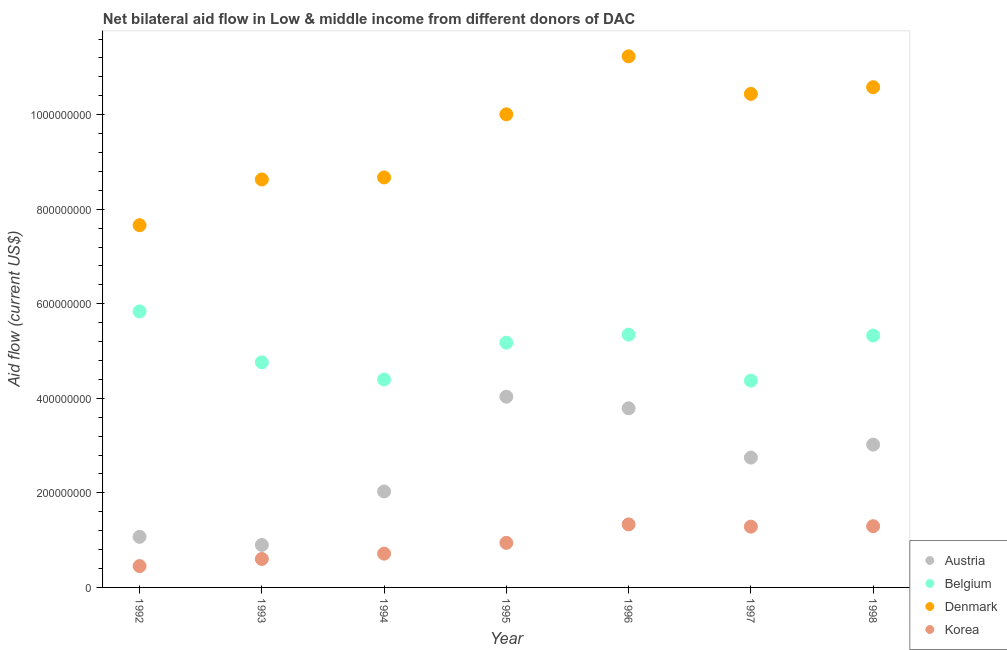What is the amount of aid given by denmark in 1995?
Make the answer very short. 1.00e+09. Across all years, what is the maximum amount of aid given by austria?
Your answer should be very brief. 4.03e+08. Across all years, what is the minimum amount of aid given by belgium?
Give a very brief answer. 4.37e+08. In which year was the amount of aid given by belgium minimum?
Ensure brevity in your answer.  1997. What is the total amount of aid given by austria in the graph?
Offer a terse response. 1.76e+09. What is the difference between the amount of aid given by korea in 1994 and that in 1997?
Your answer should be very brief. -5.71e+07. What is the difference between the amount of aid given by korea in 1998 and the amount of aid given by denmark in 1995?
Provide a short and direct response. -8.71e+08. What is the average amount of aid given by belgium per year?
Your response must be concise. 5.03e+08. In the year 1994, what is the difference between the amount of aid given by korea and amount of aid given by austria?
Make the answer very short. -1.32e+08. In how many years, is the amount of aid given by belgium greater than 1000000000 US$?
Provide a succinct answer. 0. What is the ratio of the amount of aid given by belgium in 1992 to that in 1995?
Provide a succinct answer. 1.13. Is the difference between the amount of aid given by austria in 1995 and 1997 greater than the difference between the amount of aid given by denmark in 1995 and 1997?
Ensure brevity in your answer.  Yes. What is the difference between the highest and the second highest amount of aid given by korea?
Give a very brief answer. 3.80e+06. What is the difference between the highest and the lowest amount of aid given by denmark?
Make the answer very short. 3.57e+08. In how many years, is the amount of aid given by korea greater than the average amount of aid given by korea taken over all years?
Your answer should be very brief. 3. Is the sum of the amount of aid given by austria in 1993 and 1994 greater than the maximum amount of aid given by belgium across all years?
Make the answer very short. No. Is it the case that in every year, the sum of the amount of aid given by belgium and amount of aid given by austria is greater than the sum of amount of aid given by korea and amount of aid given by denmark?
Keep it short and to the point. No. Is it the case that in every year, the sum of the amount of aid given by austria and amount of aid given by belgium is greater than the amount of aid given by denmark?
Provide a short and direct response. No. Does the amount of aid given by austria monotonically increase over the years?
Offer a terse response. No. Is the amount of aid given by korea strictly greater than the amount of aid given by belgium over the years?
Provide a succinct answer. No. Are the values on the major ticks of Y-axis written in scientific E-notation?
Your response must be concise. No. Does the graph contain any zero values?
Make the answer very short. No. Does the graph contain grids?
Your response must be concise. No. What is the title of the graph?
Your answer should be compact. Net bilateral aid flow in Low & middle income from different donors of DAC. What is the label or title of the X-axis?
Make the answer very short. Year. What is the Aid flow (current US$) of Austria in 1992?
Your answer should be very brief. 1.07e+08. What is the Aid flow (current US$) in Belgium in 1992?
Your response must be concise. 5.84e+08. What is the Aid flow (current US$) of Denmark in 1992?
Provide a short and direct response. 7.66e+08. What is the Aid flow (current US$) of Korea in 1992?
Provide a succinct answer. 4.52e+07. What is the Aid flow (current US$) of Austria in 1993?
Make the answer very short. 8.98e+07. What is the Aid flow (current US$) of Belgium in 1993?
Give a very brief answer. 4.76e+08. What is the Aid flow (current US$) in Denmark in 1993?
Keep it short and to the point. 8.63e+08. What is the Aid flow (current US$) in Korea in 1993?
Keep it short and to the point. 6.02e+07. What is the Aid flow (current US$) in Austria in 1994?
Give a very brief answer. 2.03e+08. What is the Aid flow (current US$) of Belgium in 1994?
Offer a very short reply. 4.40e+08. What is the Aid flow (current US$) of Denmark in 1994?
Your answer should be compact. 8.67e+08. What is the Aid flow (current US$) in Korea in 1994?
Ensure brevity in your answer.  7.14e+07. What is the Aid flow (current US$) in Austria in 1995?
Offer a terse response. 4.03e+08. What is the Aid flow (current US$) in Belgium in 1995?
Your answer should be very brief. 5.18e+08. What is the Aid flow (current US$) in Denmark in 1995?
Your response must be concise. 1.00e+09. What is the Aid flow (current US$) of Korea in 1995?
Give a very brief answer. 9.42e+07. What is the Aid flow (current US$) in Austria in 1996?
Give a very brief answer. 3.79e+08. What is the Aid flow (current US$) of Belgium in 1996?
Give a very brief answer. 5.35e+08. What is the Aid flow (current US$) of Denmark in 1996?
Offer a terse response. 1.12e+09. What is the Aid flow (current US$) in Korea in 1996?
Your answer should be compact. 1.33e+08. What is the Aid flow (current US$) of Austria in 1997?
Your response must be concise. 2.75e+08. What is the Aid flow (current US$) of Belgium in 1997?
Give a very brief answer. 4.37e+08. What is the Aid flow (current US$) in Denmark in 1997?
Your answer should be compact. 1.04e+09. What is the Aid flow (current US$) in Korea in 1997?
Provide a succinct answer. 1.29e+08. What is the Aid flow (current US$) in Austria in 1998?
Your answer should be very brief. 3.02e+08. What is the Aid flow (current US$) of Belgium in 1998?
Keep it short and to the point. 5.33e+08. What is the Aid flow (current US$) of Denmark in 1998?
Ensure brevity in your answer.  1.06e+09. What is the Aid flow (current US$) in Korea in 1998?
Give a very brief answer. 1.30e+08. Across all years, what is the maximum Aid flow (current US$) of Austria?
Make the answer very short. 4.03e+08. Across all years, what is the maximum Aid flow (current US$) in Belgium?
Provide a short and direct response. 5.84e+08. Across all years, what is the maximum Aid flow (current US$) in Denmark?
Your answer should be compact. 1.12e+09. Across all years, what is the maximum Aid flow (current US$) of Korea?
Provide a succinct answer. 1.33e+08. Across all years, what is the minimum Aid flow (current US$) of Austria?
Your answer should be very brief. 8.98e+07. Across all years, what is the minimum Aid flow (current US$) of Belgium?
Make the answer very short. 4.37e+08. Across all years, what is the minimum Aid flow (current US$) of Denmark?
Your response must be concise. 7.66e+08. Across all years, what is the minimum Aid flow (current US$) of Korea?
Provide a short and direct response. 4.52e+07. What is the total Aid flow (current US$) in Austria in the graph?
Your response must be concise. 1.76e+09. What is the total Aid flow (current US$) of Belgium in the graph?
Make the answer very short. 3.52e+09. What is the total Aid flow (current US$) of Denmark in the graph?
Your answer should be very brief. 6.72e+09. What is the total Aid flow (current US$) of Korea in the graph?
Offer a terse response. 6.62e+08. What is the difference between the Aid flow (current US$) in Austria in 1992 and that in 1993?
Keep it short and to the point. 1.72e+07. What is the difference between the Aid flow (current US$) in Belgium in 1992 and that in 1993?
Keep it short and to the point. 1.08e+08. What is the difference between the Aid flow (current US$) in Denmark in 1992 and that in 1993?
Make the answer very short. -9.67e+07. What is the difference between the Aid flow (current US$) in Korea in 1992 and that in 1993?
Keep it short and to the point. -1.50e+07. What is the difference between the Aid flow (current US$) of Austria in 1992 and that in 1994?
Your answer should be compact. -9.60e+07. What is the difference between the Aid flow (current US$) of Belgium in 1992 and that in 1994?
Provide a succinct answer. 1.44e+08. What is the difference between the Aid flow (current US$) of Denmark in 1992 and that in 1994?
Provide a succinct answer. -1.01e+08. What is the difference between the Aid flow (current US$) in Korea in 1992 and that in 1994?
Offer a terse response. -2.63e+07. What is the difference between the Aid flow (current US$) of Austria in 1992 and that in 1995?
Give a very brief answer. -2.96e+08. What is the difference between the Aid flow (current US$) of Belgium in 1992 and that in 1995?
Give a very brief answer. 6.62e+07. What is the difference between the Aid flow (current US$) of Denmark in 1992 and that in 1995?
Your answer should be very brief. -2.35e+08. What is the difference between the Aid flow (current US$) in Korea in 1992 and that in 1995?
Your answer should be compact. -4.91e+07. What is the difference between the Aid flow (current US$) in Austria in 1992 and that in 1996?
Your answer should be compact. -2.72e+08. What is the difference between the Aid flow (current US$) in Belgium in 1992 and that in 1996?
Provide a short and direct response. 4.92e+07. What is the difference between the Aid flow (current US$) in Denmark in 1992 and that in 1996?
Ensure brevity in your answer.  -3.57e+08. What is the difference between the Aid flow (current US$) of Korea in 1992 and that in 1996?
Your response must be concise. -8.82e+07. What is the difference between the Aid flow (current US$) in Austria in 1992 and that in 1997?
Offer a very short reply. -1.68e+08. What is the difference between the Aid flow (current US$) in Belgium in 1992 and that in 1997?
Offer a very short reply. 1.46e+08. What is the difference between the Aid flow (current US$) of Denmark in 1992 and that in 1997?
Your answer should be compact. -2.78e+08. What is the difference between the Aid flow (current US$) in Korea in 1992 and that in 1997?
Offer a terse response. -8.34e+07. What is the difference between the Aid flow (current US$) of Austria in 1992 and that in 1998?
Provide a succinct answer. -1.95e+08. What is the difference between the Aid flow (current US$) of Belgium in 1992 and that in 1998?
Give a very brief answer. 5.10e+07. What is the difference between the Aid flow (current US$) in Denmark in 1992 and that in 1998?
Your answer should be very brief. -2.92e+08. What is the difference between the Aid flow (current US$) of Korea in 1992 and that in 1998?
Make the answer very short. -8.44e+07. What is the difference between the Aid flow (current US$) of Austria in 1993 and that in 1994?
Provide a short and direct response. -1.13e+08. What is the difference between the Aid flow (current US$) in Belgium in 1993 and that in 1994?
Give a very brief answer. 3.64e+07. What is the difference between the Aid flow (current US$) in Denmark in 1993 and that in 1994?
Offer a very short reply. -4.30e+06. What is the difference between the Aid flow (current US$) of Korea in 1993 and that in 1994?
Provide a succinct answer. -1.12e+07. What is the difference between the Aid flow (current US$) in Austria in 1993 and that in 1995?
Provide a succinct answer. -3.14e+08. What is the difference between the Aid flow (current US$) of Belgium in 1993 and that in 1995?
Offer a very short reply. -4.15e+07. What is the difference between the Aid flow (current US$) of Denmark in 1993 and that in 1995?
Provide a short and direct response. -1.38e+08. What is the difference between the Aid flow (current US$) in Korea in 1993 and that in 1995?
Your answer should be very brief. -3.40e+07. What is the difference between the Aid flow (current US$) in Austria in 1993 and that in 1996?
Keep it short and to the point. -2.89e+08. What is the difference between the Aid flow (current US$) of Belgium in 1993 and that in 1996?
Ensure brevity in your answer.  -5.85e+07. What is the difference between the Aid flow (current US$) of Denmark in 1993 and that in 1996?
Your answer should be compact. -2.61e+08. What is the difference between the Aid flow (current US$) in Korea in 1993 and that in 1996?
Keep it short and to the point. -7.31e+07. What is the difference between the Aid flow (current US$) of Austria in 1993 and that in 1997?
Ensure brevity in your answer.  -1.85e+08. What is the difference between the Aid flow (current US$) in Belgium in 1993 and that in 1997?
Provide a succinct answer. 3.87e+07. What is the difference between the Aid flow (current US$) of Denmark in 1993 and that in 1997?
Your answer should be very brief. -1.81e+08. What is the difference between the Aid flow (current US$) in Korea in 1993 and that in 1997?
Give a very brief answer. -6.84e+07. What is the difference between the Aid flow (current US$) in Austria in 1993 and that in 1998?
Your answer should be compact. -2.12e+08. What is the difference between the Aid flow (current US$) in Belgium in 1993 and that in 1998?
Offer a very short reply. -5.66e+07. What is the difference between the Aid flow (current US$) in Denmark in 1993 and that in 1998?
Your answer should be compact. -1.95e+08. What is the difference between the Aid flow (current US$) of Korea in 1993 and that in 1998?
Provide a succinct answer. -6.93e+07. What is the difference between the Aid flow (current US$) in Austria in 1994 and that in 1995?
Provide a short and direct response. -2.00e+08. What is the difference between the Aid flow (current US$) of Belgium in 1994 and that in 1995?
Make the answer very short. -7.78e+07. What is the difference between the Aid flow (current US$) in Denmark in 1994 and that in 1995?
Keep it short and to the point. -1.34e+08. What is the difference between the Aid flow (current US$) in Korea in 1994 and that in 1995?
Ensure brevity in your answer.  -2.28e+07. What is the difference between the Aid flow (current US$) of Austria in 1994 and that in 1996?
Provide a succinct answer. -1.76e+08. What is the difference between the Aid flow (current US$) of Belgium in 1994 and that in 1996?
Keep it short and to the point. -9.49e+07. What is the difference between the Aid flow (current US$) of Denmark in 1994 and that in 1996?
Offer a very short reply. -2.56e+08. What is the difference between the Aid flow (current US$) of Korea in 1994 and that in 1996?
Provide a succinct answer. -6.19e+07. What is the difference between the Aid flow (current US$) of Austria in 1994 and that in 1997?
Provide a short and direct response. -7.16e+07. What is the difference between the Aid flow (current US$) of Belgium in 1994 and that in 1997?
Your answer should be very brief. 2.37e+06. What is the difference between the Aid flow (current US$) of Denmark in 1994 and that in 1997?
Provide a succinct answer. -1.77e+08. What is the difference between the Aid flow (current US$) of Korea in 1994 and that in 1997?
Your response must be concise. -5.71e+07. What is the difference between the Aid flow (current US$) in Austria in 1994 and that in 1998?
Your answer should be very brief. -9.91e+07. What is the difference between the Aid flow (current US$) in Belgium in 1994 and that in 1998?
Give a very brief answer. -9.30e+07. What is the difference between the Aid flow (current US$) in Denmark in 1994 and that in 1998?
Offer a very short reply. -1.91e+08. What is the difference between the Aid flow (current US$) in Korea in 1994 and that in 1998?
Give a very brief answer. -5.81e+07. What is the difference between the Aid flow (current US$) in Austria in 1995 and that in 1996?
Make the answer very short. 2.46e+07. What is the difference between the Aid flow (current US$) in Belgium in 1995 and that in 1996?
Your response must be concise. -1.70e+07. What is the difference between the Aid flow (current US$) of Denmark in 1995 and that in 1996?
Ensure brevity in your answer.  -1.23e+08. What is the difference between the Aid flow (current US$) of Korea in 1995 and that in 1996?
Provide a short and direct response. -3.91e+07. What is the difference between the Aid flow (current US$) in Austria in 1995 and that in 1997?
Offer a terse response. 1.29e+08. What is the difference between the Aid flow (current US$) of Belgium in 1995 and that in 1997?
Offer a very short reply. 8.02e+07. What is the difference between the Aid flow (current US$) in Denmark in 1995 and that in 1997?
Provide a succinct answer. -4.32e+07. What is the difference between the Aid flow (current US$) in Korea in 1995 and that in 1997?
Keep it short and to the point. -3.43e+07. What is the difference between the Aid flow (current US$) of Austria in 1995 and that in 1998?
Ensure brevity in your answer.  1.01e+08. What is the difference between the Aid flow (current US$) in Belgium in 1995 and that in 1998?
Make the answer very short. -1.52e+07. What is the difference between the Aid flow (current US$) of Denmark in 1995 and that in 1998?
Your answer should be compact. -5.73e+07. What is the difference between the Aid flow (current US$) of Korea in 1995 and that in 1998?
Your answer should be very brief. -3.53e+07. What is the difference between the Aid flow (current US$) of Austria in 1996 and that in 1997?
Your answer should be compact. 1.04e+08. What is the difference between the Aid flow (current US$) in Belgium in 1996 and that in 1997?
Your answer should be very brief. 9.72e+07. What is the difference between the Aid flow (current US$) in Denmark in 1996 and that in 1997?
Provide a succinct answer. 7.95e+07. What is the difference between the Aid flow (current US$) in Korea in 1996 and that in 1997?
Ensure brevity in your answer.  4.76e+06. What is the difference between the Aid flow (current US$) of Austria in 1996 and that in 1998?
Your answer should be compact. 7.69e+07. What is the difference between the Aid flow (current US$) in Belgium in 1996 and that in 1998?
Offer a terse response. 1.85e+06. What is the difference between the Aid flow (current US$) in Denmark in 1996 and that in 1998?
Provide a succinct answer. 6.54e+07. What is the difference between the Aid flow (current US$) of Korea in 1996 and that in 1998?
Provide a short and direct response. 3.80e+06. What is the difference between the Aid flow (current US$) in Austria in 1997 and that in 1998?
Your answer should be very brief. -2.74e+07. What is the difference between the Aid flow (current US$) of Belgium in 1997 and that in 1998?
Your answer should be compact. -9.54e+07. What is the difference between the Aid flow (current US$) of Denmark in 1997 and that in 1998?
Give a very brief answer. -1.42e+07. What is the difference between the Aid flow (current US$) of Korea in 1997 and that in 1998?
Your answer should be compact. -9.60e+05. What is the difference between the Aid flow (current US$) in Austria in 1992 and the Aid flow (current US$) in Belgium in 1993?
Give a very brief answer. -3.69e+08. What is the difference between the Aid flow (current US$) in Austria in 1992 and the Aid flow (current US$) in Denmark in 1993?
Keep it short and to the point. -7.56e+08. What is the difference between the Aid flow (current US$) in Austria in 1992 and the Aid flow (current US$) in Korea in 1993?
Keep it short and to the point. 4.68e+07. What is the difference between the Aid flow (current US$) of Belgium in 1992 and the Aid flow (current US$) of Denmark in 1993?
Provide a succinct answer. -2.79e+08. What is the difference between the Aid flow (current US$) in Belgium in 1992 and the Aid flow (current US$) in Korea in 1993?
Give a very brief answer. 5.24e+08. What is the difference between the Aid flow (current US$) of Denmark in 1992 and the Aid flow (current US$) of Korea in 1993?
Offer a very short reply. 7.06e+08. What is the difference between the Aid flow (current US$) in Austria in 1992 and the Aid flow (current US$) in Belgium in 1994?
Offer a terse response. -3.33e+08. What is the difference between the Aid flow (current US$) of Austria in 1992 and the Aid flow (current US$) of Denmark in 1994?
Give a very brief answer. -7.60e+08. What is the difference between the Aid flow (current US$) in Austria in 1992 and the Aid flow (current US$) in Korea in 1994?
Make the answer very short. 3.56e+07. What is the difference between the Aid flow (current US$) of Belgium in 1992 and the Aid flow (current US$) of Denmark in 1994?
Your answer should be very brief. -2.83e+08. What is the difference between the Aid flow (current US$) in Belgium in 1992 and the Aid flow (current US$) in Korea in 1994?
Offer a very short reply. 5.12e+08. What is the difference between the Aid flow (current US$) of Denmark in 1992 and the Aid flow (current US$) of Korea in 1994?
Give a very brief answer. 6.95e+08. What is the difference between the Aid flow (current US$) of Austria in 1992 and the Aid flow (current US$) of Belgium in 1995?
Your answer should be compact. -4.11e+08. What is the difference between the Aid flow (current US$) in Austria in 1992 and the Aid flow (current US$) in Denmark in 1995?
Ensure brevity in your answer.  -8.94e+08. What is the difference between the Aid flow (current US$) of Austria in 1992 and the Aid flow (current US$) of Korea in 1995?
Your answer should be compact. 1.28e+07. What is the difference between the Aid flow (current US$) in Belgium in 1992 and the Aid flow (current US$) in Denmark in 1995?
Your answer should be compact. -4.17e+08. What is the difference between the Aid flow (current US$) of Belgium in 1992 and the Aid flow (current US$) of Korea in 1995?
Offer a terse response. 4.90e+08. What is the difference between the Aid flow (current US$) in Denmark in 1992 and the Aid flow (current US$) in Korea in 1995?
Your answer should be compact. 6.72e+08. What is the difference between the Aid flow (current US$) of Austria in 1992 and the Aid flow (current US$) of Belgium in 1996?
Give a very brief answer. -4.28e+08. What is the difference between the Aid flow (current US$) of Austria in 1992 and the Aid flow (current US$) of Denmark in 1996?
Ensure brevity in your answer.  -1.02e+09. What is the difference between the Aid flow (current US$) in Austria in 1992 and the Aid flow (current US$) in Korea in 1996?
Offer a terse response. -2.63e+07. What is the difference between the Aid flow (current US$) in Belgium in 1992 and the Aid flow (current US$) in Denmark in 1996?
Provide a succinct answer. -5.40e+08. What is the difference between the Aid flow (current US$) of Belgium in 1992 and the Aid flow (current US$) of Korea in 1996?
Give a very brief answer. 4.51e+08. What is the difference between the Aid flow (current US$) in Denmark in 1992 and the Aid flow (current US$) in Korea in 1996?
Your answer should be compact. 6.33e+08. What is the difference between the Aid flow (current US$) of Austria in 1992 and the Aid flow (current US$) of Belgium in 1997?
Give a very brief answer. -3.30e+08. What is the difference between the Aid flow (current US$) of Austria in 1992 and the Aid flow (current US$) of Denmark in 1997?
Give a very brief answer. -9.37e+08. What is the difference between the Aid flow (current US$) in Austria in 1992 and the Aid flow (current US$) in Korea in 1997?
Provide a short and direct response. -2.15e+07. What is the difference between the Aid flow (current US$) of Belgium in 1992 and the Aid flow (current US$) of Denmark in 1997?
Your response must be concise. -4.60e+08. What is the difference between the Aid flow (current US$) in Belgium in 1992 and the Aid flow (current US$) in Korea in 1997?
Make the answer very short. 4.55e+08. What is the difference between the Aid flow (current US$) in Denmark in 1992 and the Aid flow (current US$) in Korea in 1997?
Give a very brief answer. 6.38e+08. What is the difference between the Aid flow (current US$) of Austria in 1992 and the Aid flow (current US$) of Belgium in 1998?
Keep it short and to the point. -4.26e+08. What is the difference between the Aid flow (current US$) of Austria in 1992 and the Aid flow (current US$) of Denmark in 1998?
Your answer should be compact. -9.51e+08. What is the difference between the Aid flow (current US$) in Austria in 1992 and the Aid flow (current US$) in Korea in 1998?
Ensure brevity in your answer.  -2.25e+07. What is the difference between the Aid flow (current US$) in Belgium in 1992 and the Aid flow (current US$) in Denmark in 1998?
Ensure brevity in your answer.  -4.74e+08. What is the difference between the Aid flow (current US$) in Belgium in 1992 and the Aid flow (current US$) in Korea in 1998?
Your answer should be compact. 4.54e+08. What is the difference between the Aid flow (current US$) in Denmark in 1992 and the Aid flow (current US$) in Korea in 1998?
Your answer should be very brief. 6.37e+08. What is the difference between the Aid flow (current US$) of Austria in 1993 and the Aid flow (current US$) of Belgium in 1994?
Offer a terse response. -3.50e+08. What is the difference between the Aid flow (current US$) in Austria in 1993 and the Aid flow (current US$) in Denmark in 1994?
Offer a terse response. -7.77e+08. What is the difference between the Aid flow (current US$) in Austria in 1993 and the Aid flow (current US$) in Korea in 1994?
Your answer should be very brief. 1.84e+07. What is the difference between the Aid flow (current US$) in Belgium in 1993 and the Aid flow (current US$) in Denmark in 1994?
Give a very brief answer. -3.91e+08. What is the difference between the Aid flow (current US$) in Belgium in 1993 and the Aid flow (current US$) in Korea in 1994?
Give a very brief answer. 4.05e+08. What is the difference between the Aid flow (current US$) of Denmark in 1993 and the Aid flow (current US$) of Korea in 1994?
Your answer should be compact. 7.91e+08. What is the difference between the Aid flow (current US$) of Austria in 1993 and the Aid flow (current US$) of Belgium in 1995?
Offer a terse response. -4.28e+08. What is the difference between the Aid flow (current US$) of Austria in 1993 and the Aid flow (current US$) of Denmark in 1995?
Provide a succinct answer. -9.11e+08. What is the difference between the Aid flow (current US$) of Austria in 1993 and the Aid flow (current US$) of Korea in 1995?
Your answer should be compact. -4.40e+06. What is the difference between the Aid flow (current US$) of Belgium in 1993 and the Aid flow (current US$) of Denmark in 1995?
Your answer should be very brief. -5.25e+08. What is the difference between the Aid flow (current US$) of Belgium in 1993 and the Aid flow (current US$) of Korea in 1995?
Keep it short and to the point. 3.82e+08. What is the difference between the Aid flow (current US$) in Denmark in 1993 and the Aid flow (current US$) in Korea in 1995?
Your answer should be compact. 7.69e+08. What is the difference between the Aid flow (current US$) in Austria in 1993 and the Aid flow (current US$) in Belgium in 1996?
Provide a succinct answer. -4.45e+08. What is the difference between the Aid flow (current US$) in Austria in 1993 and the Aid flow (current US$) in Denmark in 1996?
Provide a short and direct response. -1.03e+09. What is the difference between the Aid flow (current US$) of Austria in 1993 and the Aid flow (current US$) of Korea in 1996?
Make the answer very short. -4.35e+07. What is the difference between the Aid flow (current US$) in Belgium in 1993 and the Aid flow (current US$) in Denmark in 1996?
Provide a succinct answer. -6.47e+08. What is the difference between the Aid flow (current US$) of Belgium in 1993 and the Aid flow (current US$) of Korea in 1996?
Offer a very short reply. 3.43e+08. What is the difference between the Aid flow (current US$) in Denmark in 1993 and the Aid flow (current US$) in Korea in 1996?
Make the answer very short. 7.30e+08. What is the difference between the Aid flow (current US$) in Austria in 1993 and the Aid flow (current US$) in Belgium in 1997?
Make the answer very short. -3.48e+08. What is the difference between the Aid flow (current US$) in Austria in 1993 and the Aid flow (current US$) in Denmark in 1997?
Make the answer very short. -9.54e+08. What is the difference between the Aid flow (current US$) in Austria in 1993 and the Aid flow (current US$) in Korea in 1997?
Offer a terse response. -3.87e+07. What is the difference between the Aid flow (current US$) of Belgium in 1993 and the Aid flow (current US$) of Denmark in 1997?
Your answer should be compact. -5.68e+08. What is the difference between the Aid flow (current US$) of Belgium in 1993 and the Aid flow (current US$) of Korea in 1997?
Give a very brief answer. 3.48e+08. What is the difference between the Aid flow (current US$) of Denmark in 1993 and the Aid flow (current US$) of Korea in 1997?
Your answer should be very brief. 7.34e+08. What is the difference between the Aid flow (current US$) in Austria in 1993 and the Aid flow (current US$) in Belgium in 1998?
Your answer should be compact. -4.43e+08. What is the difference between the Aid flow (current US$) of Austria in 1993 and the Aid flow (current US$) of Denmark in 1998?
Offer a terse response. -9.68e+08. What is the difference between the Aid flow (current US$) in Austria in 1993 and the Aid flow (current US$) in Korea in 1998?
Offer a terse response. -3.97e+07. What is the difference between the Aid flow (current US$) of Belgium in 1993 and the Aid flow (current US$) of Denmark in 1998?
Your response must be concise. -5.82e+08. What is the difference between the Aid flow (current US$) of Belgium in 1993 and the Aid flow (current US$) of Korea in 1998?
Your answer should be compact. 3.47e+08. What is the difference between the Aid flow (current US$) of Denmark in 1993 and the Aid flow (current US$) of Korea in 1998?
Your answer should be very brief. 7.33e+08. What is the difference between the Aid flow (current US$) in Austria in 1994 and the Aid flow (current US$) in Belgium in 1995?
Keep it short and to the point. -3.15e+08. What is the difference between the Aid flow (current US$) in Austria in 1994 and the Aid flow (current US$) in Denmark in 1995?
Give a very brief answer. -7.98e+08. What is the difference between the Aid flow (current US$) in Austria in 1994 and the Aid flow (current US$) in Korea in 1995?
Your answer should be very brief. 1.09e+08. What is the difference between the Aid flow (current US$) in Belgium in 1994 and the Aid flow (current US$) in Denmark in 1995?
Ensure brevity in your answer.  -5.61e+08. What is the difference between the Aid flow (current US$) in Belgium in 1994 and the Aid flow (current US$) in Korea in 1995?
Your response must be concise. 3.46e+08. What is the difference between the Aid flow (current US$) of Denmark in 1994 and the Aid flow (current US$) of Korea in 1995?
Your answer should be compact. 7.73e+08. What is the difference between the Aid flow (current US$) in Austria in 1994 and the Aid flow (current US$) in Belgium in 1996?
Your answer should be very brief. -3.32e+08. What is the difference between the Aid flow (current US$) of Austria in 1994 and the Aid flow (current US$) of Denmark in 1996?
Ensure brevity in your answer.  -9.20e+08. What is the difference between the Aid flow (current US$) of Austria in 1994 and the Aid flow (current US$) of Korea in 1996?
Ensure brevity in your answer.  6.97e+07. What is the difference between the Aid flow (current US$) of Belgium in 1994 and the Aid flow (current US$) of Denmark in 1996?
Give a very brief answer. -6.84e+08. What is the difference between the Aid flow (current US$) of Belgium in 1994 and the Aid flow (current US$) of Korea in 1996?
Your answer should be very brief. 3.07e+08. What is the difference between the Aid flow (current US$) in Denmark in 1994 and the Aid flow (current US$) in Korea in 1996?
Make the answer very short. 7.34e+08. What is the difference between the Aid flow (current US$) in Austria in 1994 and the Aid flow (current US$) in Belgium in 1997?
Your response must be concise. -2.34e+08. What is the difference between the Aid flow (current US$) in Austria in 1994 and the Aid flow (current US$) in Denmark in 1997?
Offer a terse response. -8.41e+08. What is the difference between the Aid flow (current US$) of Austria in 1994 and the Aid flow (current US$) of Korea in 1997?
Your response must be concise. 7.44e+07. What is the difference between the Aid flow (current US$) of Belgium in 1994 and the Aid flow (current US$) of Denmark in 1997?
Offer a very short reply. -6.04e+08. What is the difference between the Aid flow (current US$) of Belgium in 1994 and the Aid flow (current US$) of Korea in 1997?
Ensure brevity in your answer.  3.11e+08. What is the difference between the Aid flow (current US$) in Denmark in 1994 and the Aid flow (current US$) in Korea in 1997?
Make the answer very short. 7.39e+08. What is the difference between the Aid flow (current US$) of Austria in 1994 and the Aid flow (current US$) of Belgium in 1998?
Offer a very short reply. -3.30e+08. What is the difference between the Aid flow (current US$) of Austria in 1994 and the Aid flow (current US$) of Denmark in 1998?
Provide a succinct answer. -8.55e+08. What is the difference between the Aid flow (current US$) of Austria in 1994 and the Aid flow (current US$) of Korea in 1998?
Offer a terse response. 7.35e+07. What is the difference between the Aid flow (current US$) in Belgium in 1994 and the Aid flow (current US$) in Denmark in 1998?
Offer a very short reply. -6.18e+08. What is the difference between the Aid flow (current US$) in Belgium in 1994 and the Aid flow (current US$) in Korea in 1998?
Your answer should be compact. 3.10e+08. What is the difference between the Aid flow (current US$) of Denmark in 1994 and the Aid flow (current US$) of Korea in 1998?
Make the answer very short. 7.38e+08. What is the difference between the Aid flow (current US$) of Austria in 1995 and the Aid flow (current US$) of Belgium in 1996?
Provide a succinct answer. -1.31e+08. What is the difference between the Aid flow (current US$) in Austria in 1995 and the Aid flow (current US$) in Denmark in 1996?
Offer a terse response. -7.20e+08. What is the difference between the Aid flow (current US$) in Austria in 1995 and the Aid flow (current US$) in Korea in 1996?
Provide a succinct answer. 2.70e+08. What is the difference between the Aid flow (current US$) of Belgium in 1995 and the Aid flow (current US$) of Denmark in 1996?
Give a very brief answer. -6.06e+08. What is the difference between the Aid flow (current US$) in Belgium in 1995 and the Aid flow (current US$) in Korea in 1996?
Offer a terse response. 3.84e+08. What is the difference between the Aid flow (current US$) of Denmark in 1995 and the Aid flow (current US$) of Korea in 1996?
Provide a short and direct response. 8.67e+08. What is the difference between the Aid flow (current US$) in Austria in 1995 and the Aid flow (current US$) in Belgium in 1997?
Provide a succinct answer. -3.40e+07. What is the difference between the Aid flow (current US$) of Austria in 1995 and the Aid flow (current US$) of Denmark in 1997?
Keep it short and to the point. -6.40e+08. What is the difference between the Aid flow (current US$) of Austria in 1995 and the Aid flow (current US$) of Korea in 1997?
Provide a succinct answer. 2.75e+08. What is the difference between the Aid flow (current US$) in Belgium in 1995 and the Aid flow (current US$) in Denmark in 1997?
Give a very brief answer. -5.26e+08. What is the difference between the Aid flow (current US$) in Belgium in 1995 and the Aid flow (current US$) in Korea in 1997?
Your answer should be very brief. 3.89e+08. What is the difference between the Aid flow (current US$) in Denmark in 1995 and the Aid flow (current US$) in Korea in 1997?
Give a very brief answer. 8.72e+08. What is the difference between the Aid flow (current US$) of Austria in 1995 and the Aid flow (current US$) of Belgium in 1998?
Your answer should be compact. -1.29e+08. What is the difference between the Aid flow (current US$) in Austria in 1995 and the Aid flow (current US$) in Denmark in 1998?
Keep it short and to the point. -6.55e+08. What is the difference between the Aid flow (current US$) of Austria in 1995 and the Aid flow (current US$) of Korea in 1998?
Offer a very short reply. 2.74e+08. What is the difference between the Aid flow (current US$) in Belgium in 1995 and the Aid flow (current US$) in Denmark in 1998?
Offer a very short reply. -5.40e+08. What is the difference between the Aid flow (current US$) of Belgium in 1995 and the Aid flow (current US$) of Korea in 1998?
Your answer should be compact. 3.88e+08. What is the difference between the Aid flow (current US$) in Denmark in 1995 and the Aid flow (current US$) in Korea in 1998?
Your answer should be very brief. 8.71e+08. What is the difference between the Aid flow (current US$) in Austria in 1996 and the Aid flow (current US$) in Belgium in 1997?
Give a very brief answer. -5.85e+07. What is the difference between the Aid flow (current US$) of Austria in 1996 and the Aid flow (current US$) of Denmark in 1997?
Give a very brief answer. -6.65e+08. What is the difference between the Aid flow (current US$) in Austria in 1996 and the Aid flow (current US$) in Korea in 1997?
Offer a terse response. 2.50e+08. What is the difference between the Aid flow (current US$) of Belgium in 1996 and the Aid flow (current US$) of Denmark in 1997?
Provide a short and direct response. -5.09e+08. What is the difference between the Aid flow (current US$) of Belgium in 1996 and the Aid flow (current US$) of Korea in 1997?
Provide a succinct answer. 4.06e+08. What is the difference between the Aid flow (current US$) of Denmark in 1996 and the Aid flow (current US$) of Korea in 1997?
Keep it short and to the point. 9.95e+08. What is the difference between the Aid flow (current US$) of Austria in 1996 and the Aid flow (current US$) of Belgium in 1998?
Ensure brevity in your answer.  -1.54e+08. What is the difference between the Aid flow (current US$) in Austria in 1996 and the Aid flow (current US$) in Denmark in 1998?
Make the answer very short. -6.79e+08. What is the difference between the Aid flow (current US$) of Austria in 1996 and the Aid flow (current US$) of Korea in 1998?
Offer a very short reply. 2.49e+08. What is the difference between the Aid flow (current US$) of Belgium in 1996 and the Aid flow (current US$) of Denmark in 1998?
Your response must be concise. -5.23e+08. What is the difference between the Aid flow (current US$) of Belgium in 1996 and the Aid flow (current US$) of Korea in 1998?
Provide a succinct answer. 4.05e+08. What is the difference between the Aid flow (current US$) of Denmark in 1996 and the Aid flow (current US$) of Korea in 1998?
Offer a very short reply. 9.94e+08. What is the difference between the Aid flow (current US$) of Austria in 1997 and the Aid flow (current US$) of Belgium in 1998?
Your answer should be very brief. -2.58e+08. What is the difference between the Aid flow (current US$) in Austria in 1997 and the Aid flow (current US$) in Denmark in 1998?
Your response must be concise. -7.83e+08. What is the difference between the Aid flow (current US$) of Austria in 1997 and the Aid flow (current US$) of Korea in 1998?
Provide a succinct answer. 1.45e+08. What is the difference between the Aid flow (current US$) in Belgium in 1997 and the Aid flow (current US$) in Denmark in 1998?
Your response must be concise. -6.21e+08. What is the difference between the Aid flow (current US$) in Belgium in 1997 and the Aid flow (current US$) in Korea in 1998?
Give a very brief answer. 3.08e+08. What is the difference between the Aid flow (current US$) in Denmark in 1997 and the Aid flow (current US$) in Korea in 1998?
Offer a very short reply. 9.14e+08. What is the average Aid flow (current US$) in Austria per year?
Keep it short and to the point. 2.51e+08. What is the average Aid flow (current US$) in Belgium per year?
Offer a terse response. 5.03e+08. What is the average Aid flow (current US$) of Denmark per year?
Provide a succinct answer. 9.60e+08. What is the average Aid flow (current US$) of Korea per year?
Your answer should be compact. 9.46e+07. In the year 1992, what is the difference between the Aid flow (current US$) in Austria and Aid flow (current US$) in Belgium?
Ensure brevity in your answer.  -4.77e+08. In the year 1992, what is the difference between the Aid flow (current US$) of Austria and Aid flow (current US$) of Denmark?
Make the answer very short. -6.59e+08. In the year 1992, what is the difference between the Aid flow (current US$) in Austria and Aid flow (current US$) in Korea?
Offer a very short reply. 6.19e+07. In the year 1992, what is the difference between the Aid flow (current US$) in Belgium and Aid flow (current US$) in Denmark?
Your answer should be compact. -1.82e+08. In the year 1992, what is the difference between the Aid flow (current US$) in Belgium and Aid flow (current US$) in Korea?
Provide a succinct answer. 5.39e+08. In the year 1992, what is the difference between the Aid flow (current US$) of Denmark and Aid flow (current US$) of Korea?
Give a very brief answer. 7.21e+08. In the year 1993, what is the difference between the Aid flow (current US$) of Austria and Aid flow (current US$) of Belgium?
Ensure brevity in your answer.  -3.86e+08. In the year 1993, what is the difference between the Aid flow (current US$) of Austria and Aid flow (current US$) of Denmark?
Offer a very short reply. -7.73e+08. In the year 1993, what is the difference between the Aid flow (current US$) of Austria and Aid flow (current US$) of Korea?
Your response must be concise. 2.96e+07. In the year 1993, what is the difference between the Aid flow (current US$) in Belgium and Aid flow (current US$) in Denmark?
Your answer should be very brief. -3.87e+08. In the year 1993, what is the difference between the Aid flow (current US$) in Belgium and Aid flow (current US$) in Korea?
Provide a succinct answer. 4.16e+08. In the year 1993, what is the difference between the Aid flow (current US$) in Denmark and Aid flow (current US$) in Korea?
Ensure brevity in your answer.  8.03e+08. In the year 1994, what is the difference between the Aid flow (current US$) in Austria and Aid flow (current US$) in Belgium?
Your answer should be compact. -2.37e+08. In the year 1994, what is the difference between the Aid flow (current US$) of Austria and Aid flow (current US$) of Denmark?
Your answer should be compact. -6.64e+08. In the year 1994, what is the difference between the Aid flow (current US$) in Austria and Aid flow (current US$) in Korea?
Give a very brief answer. 1.32e+08. In the year 1994, what is the difference between the Aid flow (current US$) in Belgium and Aid flow (current US$) in Denmark?
Your response must be concise. -4.27e+08. In the year 1994, what is the difference between the Aid flow (current US$) of Belgium and Aid flow (current US$) of Korea?
Keep it short and to the point. 3.68e+08. In the year 1994, what is the difference between the Aid flow (current US$) in Denmark and Aid flow (current US$) in Korea?
Offer a terse response. 7.96e+08. In the year 1995, what is the difference between the Aid flow (current US$) of Austria and Aid flow (current US$) of Belgium?
Your answer should be compact. -1.14e+08. In the year 1995, what is the difference between the Aid flow (current US$) of Austria and Aid flow (current US$) of Denmark?
Your response must be concise. -5.97e+08. In the year 1995, what is the difference between the Aid flow (current US$) of Austria and Aid flow (current US$) of Korea?
Offer a terse response. 3.09e+08. In the year 1995, what is the difference between the Aid flow (current US$) of Belgium and Aid flow (current US$) of Denmark?
Provide a succinct answer. -4.83e+08. In the year 1995, what is the difference between the Aid flow (current US$) in Belgium and Aid flow (current US$) in Korea?
Provide a succinct answer. 4.23e+08. In the year 1995, what is the difference between the Aid flow (current US$) of Denmark and Aid flow (current US$) of Korea?
Provide a succinct answer. 9.07e+08. In the year 1996, what is the difference between the Aid flow (current US$) in Austria and Aid flow (current US$) in Belgium?
Ensure brevity in your answer.  -1.56e+08. In the year 1996, what is the difference between the Aid flow (current US$) in Austria and Aid flow (current US$) in Denmark?
Offer a very short reply. -7.45e+08. In the year 1996, what is the difference between the Aid flow (current US$) of Austria and Aid flow (current US$) of Korea?
Offer a terse response. 2.46e+08. In the year 1996, what is the difference between the Aid flow (current US$) in Belgium and Aid flow (current US$) in Denmark?
Make the answer very short. -5.89e+08. In the year 1996, what is the difference between the Aid flow (current US$) of Belgium and Aid flow (current US$) of Korea?
Give a very brief answer. 4.01e+08. In the year 1996, what is the difference between the Aid flow (current US$) in Denmark and Aid flow (current US$) in Korea?
Keep it short and to the point. 9.90e+08. In the year 1997, what is the difference between the Aid flow (current US$) in Austria and Aid flow (current US$) in Belgium?
Offer a very short reply. -1.63e+08. In the year 1997, what is the difference between the Aid flow (current US$) of Austria and Aid flow (current US$) of Denmark?
Ensure brevity in your answer.  -7.69e+08. In the year 1997, what is the difference between the Aid flow (current US$) of Austria and Aid flow (current US$) of Korea?
Your answer should be compact. 1.46e+08. In the year 1997, what is the difference between the Aid flow (current US$) in Belgium and Aid flow (current US$) in Denmark?
Give a very brief answer. -6.06e+08. In the year 1997, what is the difference between the Aid flow (current US$) in Belgium and Aid flow (current US$) in Korea?
Offer a terse response. 3.09e+08. In the year 1997, what is the difference between the Aid flow (current US$) in Denmark and Aid flow (current US$) in Korea?
Provide a succinct answer. 9.15e+08. In the year 1998, what is the difference between the Aid flow (current US$) of Austria and Aid flow (current US$) of Belgium?
Provide a succinct answer. -2.31e+08. In the year 1998, what is the difference between the Aid flow (current US$) in Austria and Aid flow (current US$) in Denmark?
Provide a short and direct response. -7.56e+08. In the year 1998, what is the difference between the Aid flow (current US$) of Austria and Aid flow (current US$) of Korea?
Your response must be concise. 1.73e+08. In the year 1998, what is the difference between the Aid flow (current US$) of Belgium and Aid flow (current US$) of Denmark?
Make the answer very short. -5.25e+08. In the year 1998, what is the difference between the Aid flow (current US$) of Belgium and Aid flow (current US$) of Korea?
Make the answer very short. 4.03e+08. In the year 1998, what is the difference between the Aid flow (current US$) of Denmark and Aid flow (current US$) of Korea?
Ensure brevity in your answer.  9.29e+08. What is the ratio of the Aid flow (current US$) in Austria in 1992 to that in 1993?
Offer a terse response. 1.19. What is the ratio of the Aid flow (current US$) in Belgium in 1992 to that in 1993?
Offer a terse response. 1.23. What is the ratio of the Aid flow (current US$) of Denmark in 1992 to that in 1993?
Give a very brief answer. 0.89. What is the ratio of the Aid flow (current US$) of Korea in 1992 to that in 1993?
Provide a short and direct response. 0.75. What is the ratio of the Aid flow (current US$) in Austria in 1992 to that in 1994?
Your answer should be very brief. 0.53. What is the ratio of the Aid flow (current US$) of Belgium in 1992 to that in 1994?
Keep it short and to the point. 1.33. What is the ratio of the Aid flow (current US$) of Denmark in 1992 to that in 1994?
Offer a very short reply. 0.88. What is the ratio of the Aid flow (current US$) in Korea in 1992 to that in 1994?
Offer a very short reply. 0.63. What is the ratio of the Aid flow (current US$) of Austria in 1992 to that in 1995?
Make the answer very short. 0.27. What is the ratio of the Aid flow (current US$) of Belgium in 1992 to that in 1995?
Keep it short and to the point. 1.13. What is the ratio of the Aid flow (current US$) of Denmark in 1992 to that in 1995?
Your response must be concise. 0.77. What is the ratio of the Aid flow (current US$) of Korea in 1992 to that in 1995?
Provide a succinct answer. 0.48. What is the ratio of the Aid flow (current US$) of Austria in 1992 to that in 1996?
Make the answer very short. 0.28. What is the ratio of the Aid flow (current US$) in Belgium in 1992 to that in 1996?
Offer a very short reply. 1.09. What is the ratio of the Aid flow (current US$) of Denmark in 1992 to that in 1996?
Your answer should be compact. 0.68. What is the ratio of the Aid flow (current US$) of Korea in 1992 to that in 1996?
Provide a short and direct response. 0.34. What is the ratio of the Aid flow (current US$) in Austria in 1992 to that in 1997?
Your answer should be compact. 0.39. What is the ratio of the Aid flow (current US$) in Belgium in 1992 to that in 1997?
Give a very brief answer. 1.33. What is the ratio of the Aid flow (current US$) in Denmark in 1992 to that in 1997?
Provide a succinct answer. 0.73. What is the ratio of the Aid flow (current US$) in Korea in 1992 to that in 1997?
Offer a terse response. 0.35. What is the ratio of the Aid flow (current US$) of Austria in 1992 to that in 1998?
Offer a terse response. 0.35. What is the ratio of the Aid flow (current US$) in Belgium in 1992 to that in 1998?
Ensure brevity in your answer.  1.1. What is the ratio of the Aid flow (current US$) in Denmark in 1992 to that in 1998?
Offer a very short reply. 0.72. What is the ratio of the Aid flow (current US$) in Korea in 1992 to that in 1998?
Provide a short and direct response. 0.35. What is the ratio of the Aid flow (current US$) of Austria in 1993 to that in 1994?
Your response must be concise. 0.44. What is the ratio of the Aid flow (current US$) of Belgium in 1993 to that in 1994?
Offer a terse response. 1.08. What is the ratio of the Aid flow (current US$) of Korea in 1993 to that in 1994?
Ensure brevity in your answer.  0.84. What is the ratio of the Aid flow (current US$) of Austria in 1993 to that in 1995?
Make the answer very short. 0.22. What is the ratio of the Aid flow (current US$) in Belgium in 1993 to that in 1995?
Provide a succinct answer. 0.92. What is the ratio of the Aid flow (current US$) in Denmark in 1993 to that in 1995?
Your answer should be very brief. 0.86. What is the ratio of the Aid flow (current US$) of Korea in 1993 to that in 1995?
Make the answer very short. 0.64. What is the ratio of the Aid flow (current US$) in Austria in 1993 to that in 1996?
Your response must be concise. 0.24. What is the ratio of the Aid flow (current US$) of Belgium in 1993 to that in 1996?
Ensure brevity in your answer.  0.89. What is the ratio of the Aid flow (current US$) in Denmark in 1993 to that in 1996?
Make the answer very short. 0.77. What is the ratio of the Aid flow (current US$) in Korea in 1993 to that in 1996?
Your answer should be compact. 0.45. What is the ratio of the Aid flow (current US$) in Austria in 1993 to that in 1997?
Offer a very short reply. 0.33. What is the ratio of the Aid flow (current US$) in Belgium in 1993 to that in 1997?
Your response must be concise. 1.09. What is the ratio of the Aid flow (current US$) in Denmark in 1993 to that in 1997?
Your answer should be very brief. 0.83. What is the ratio of the Aid flow (current US$) of Korea in 1993 to that in 1997?
Your response must be concise. 0.47. What is the ratio of the Aid flow (current US$) of Austria in 1993 to that in 1998?
Your answer should be very brief. 0.3. What is the ratio of the Aid flow (current US$) in Belgium in 1993 to that in 1998?
Keep it short and to the point. 0.89. What is the ratio of the Aid flow (current US$) of Denmark in 1993 to that in 1998?
Ensure brevity in your answer.  0.82. What is the ratio of the Aid flow (current US$) of Korea in 1993 to that in 1998?
Your response must be concise. 0.46. What is the ratio of the Aid flow (current US$) in Austria in 1994 to that in 1995?
Offer a very short reply. 0.5. What is the ratio of the Aid flow (current US$) in Belgium in 1994 to that in 1995?
Provide a succinct answer. 0.85. What is the ratio of the Aid flow (current US$) in Denmark in 1994 to that in 1995?
Give a very brief answer. 0.87. What is the ratio of the Aid flow (current US$) in Korea in 1994 to that in 1995?
Make the answer very short. 0.76. What is the ratio of the Aid flow (current US$) of Austria in 1994 to that in 1996?
Keep it short and to the point. 0.54. What is the ratio of the Aid flow (current US$) of Belgium in 1994 to that in 1996?
Ensure brevity in your answer.  0.82. What is the ratio of the Aid flow (current US$) in Denmark in 1994 to that in 1996?
Your response must be concise. 0.77. What is the ratio of the Aid flow (current US$) in Korea in 1994 to that in 1996?
Keep it short and to the point. 0.54. What is the ratio of the Aid flow (current US$) of Austria in 1994 to that in 1997?
Keep it short and to the point. 0.74. What is the ratio of the Aid flow (current US$) in Belgium in 1994 to that in 1997?
Ensure brevity in your answer.  1.01. What is the ratio of the Aid flow (current US$) of Denmark in 1994 to that in 1997?
Offer a terse response. 0.83. What is the ratio of the Aid flow (current US$) of Korea in 1994 to that in 1997?
Your response must be concise. 0.56. What is the ratio of the Aid flow (current US$) in Austria in 1994 to that in 1998?
Your response must be concise. 0.67. What is the ratio of the Aid flow (current US$) of Belgium in 1994 to that in 1998?
Your response must be concise. 0.83. What is the ratio of the Aid flow (current US$) in Denmark in 1994 to that in 1998?
Offer a very short reply. 0.82. What is the ratio of the Aid flow (current US$) of Korea in 1994 to that in 1998?
Your answer should be compact. 0.55. What is the ratio of the Aid flow (current US$) of Austria in 1995 to that in 1996?
Provide a short and direct response. 1.06. What is the ratio of the Aid flow (current US$) in Belgium in 1995 to that in 1996?
Give a very brief answer. 0.97. What is the ratio of the Aid flow (current US$) in Denmark in 1995 to that in 1996?
Your answer should be compact. 0.89. What is the ratio of the Aid flow (current US$) of Korea in 1995 to that in 1996?
Offer a terse response. 0.71. What is the ratio of the Aid flow (current US$) in Austria in 1995 to that in 1997?
Your answer should be very brief. 1.47. What is the ratio of the Aid flow (current US$) in Belgium in 1995 to that in 1997?
Keep it short and to the point. 1.18. What is the ratio of the Aid flow (current US$) in Denmark in 1995 to that in 1997?
Provide a succinct answer. 0.96. What is the ratio of the Aid flow (current US$) of Korea in 1995 to that in 1997?
Give a very brief answer. 0.73. What is the ratio of the Aid flow (current US$) of Austria in 1995 to that in 1998?
Your answer should be compact. 1.34. What is the ratio of the Aid flow (current US$) in Belgium in 1995 to that in 1998?
Your answer should be very brief. 0.97. What is the ratio of the Aid flow (current US$) of Denmark in 1995 to that in 1998?
Your answer should be very brief. 0.95. What is the ratio of the Aid flow (current US$) of Korea in 1995 to that in 1998?
Keep it short and to the point. 0.73. What is the ratio of the Aid flow (current US$) in Austria in 1996 to that in 1997?
Offer a terse response. 1.38. What is the ratio of the Aid flow (current US$) in Belgium in 1996 to that in 1997?
Provide a short and direct response. 1.22. What is the ratio of the Aid flow (current US$) in Denmark in 1996 to that in 1997?
Your answer should be compact. 1.08. What is the ratio of the Aid flow (current US$) in Korea in 1996 to that in 1997?
Your answer should be very brief. 1.04. What is the ratio of the Aid flow (current US$) in Austria in 1996 to that in 1998?
Your answer should be compact. 1.25. What is the ratio of the Aid flow (current US$) in Denmark in 1996 to that in 1998?
Provide a short and direct response. 1.06. What is the ratio of the Aid flow (current US$) in Korea in 1996 to that in 1998?
Ensure brevity in your answer.  1.03. What is the ratio of the Aid flow (current US$) in Austria in 1997 to that in 1998?
Your answer should be compact. 0.91. What is the ratio of the Aid flow (current US$) of Belgium in 1997 to that in 1998?
Offer a very short reply. 0.82. What is the ratio of the Aid flow (current US$) of Denmark in 1997 to that in 1998?
Ensure brevity in your answer.  0.99. What is the ratio of the Aid flow (current US$) of Korea in 1997 to that in 1998?
Keep it short and to the point. 0.99. What is the difference between the highest and the second highest Aid flow (current US$) of Austria?
Your response must be concise. 2.46e+07. What is the difference between the highest and the second highest Aid flow (current US$) in Belgium?
Your response must be concise. 4.92e+07. What is the difference between the highest and the second highest Aid flow (current US$) in Denmark?
Ensure brevity in your answer.  6.54e+07. What is the difference between the highest and the second highest Aid flow (current US$) in Korea?
Your answer should be compact. 3.80e+06. What is the difference between the highest and the lowest Aid flow (current US$) in Austria?
Ensure brevity in your answer.  3.14e+08. What is the difference between the highest and the lowest Aid flow (current US$) of Belgium?
Give a very brief answer. 1.46e+08. What is the difference between the highest and the lowest Aid flow (current US$) in Denmark?
Your answer should be compact. 3.57e+08. What is the difference between the highest and the lowest Aid flow (current US$) of Korea?
Provide a short and direct response. 8.82e+07. 